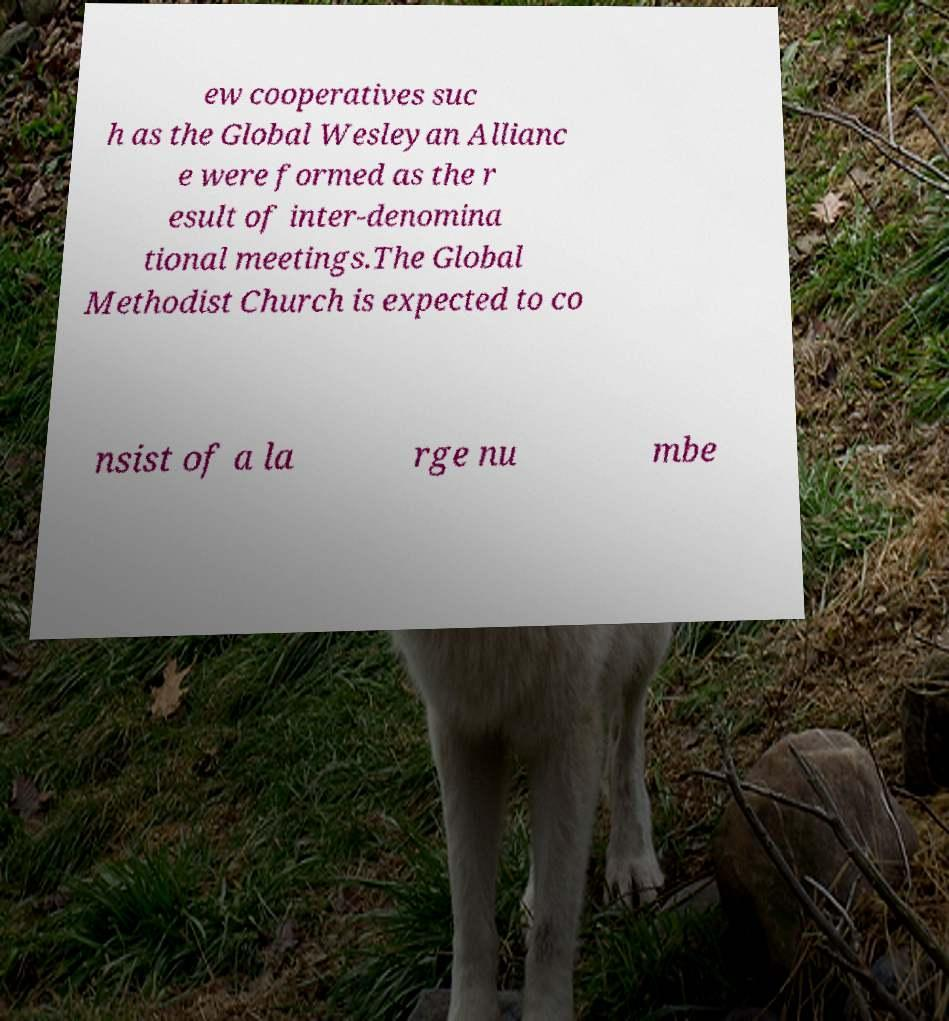What messages or text are displayed in this image? I need them in a readable, typed format. ew cooperatives suc h as the Global Wesleyan Allianc e were formed as the r esult of inter-denomina tional meetings.The Global Methodist Church is expected to co nsist of a la rge nu mbe 